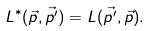Convert formula to latex. <formula><loc_0><loc_0><loc_500><loc_500>L ^ { * } ( \vec { p } , \vec { p ^ { \prime } } ) = L ( \vec { p ^ { \prime } } , \vec { p } ) .</formula> 